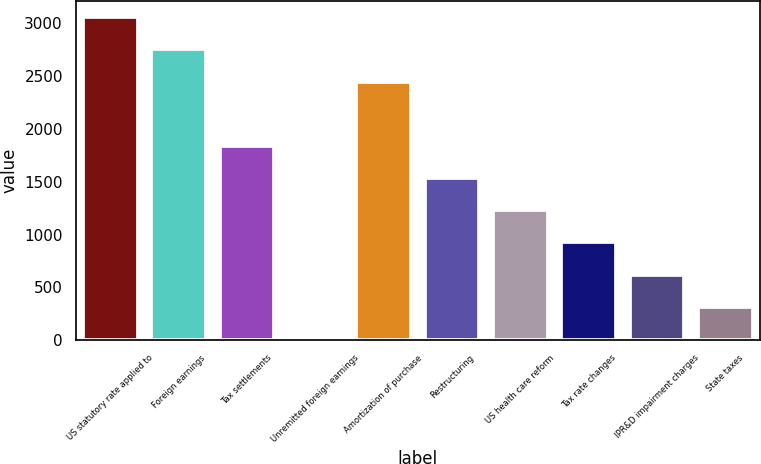Convert chart. <chart><loc_0><loc_0><loc_500><loc_500><bar_chart><fcel>US statutory rate applied to<fcel>Foreign earnings<fcel>Tax settlements<fcel>Unremitted foreign earnings<fcel>Amortization of purchase<fcel>Restructuring<fcel>US health care reform<fcel>Tax rate changes<fcel>IPR&D impairment charges<fcel>State taxes<nl><fcel>3059<fcel>2754.2<fcel>1839.8<fcel>11<fcel>2449.4<fcel>1535<fcel>1230.2<fcel>925.4<fcel>620.6<fcel>315.8<nl></chart> 